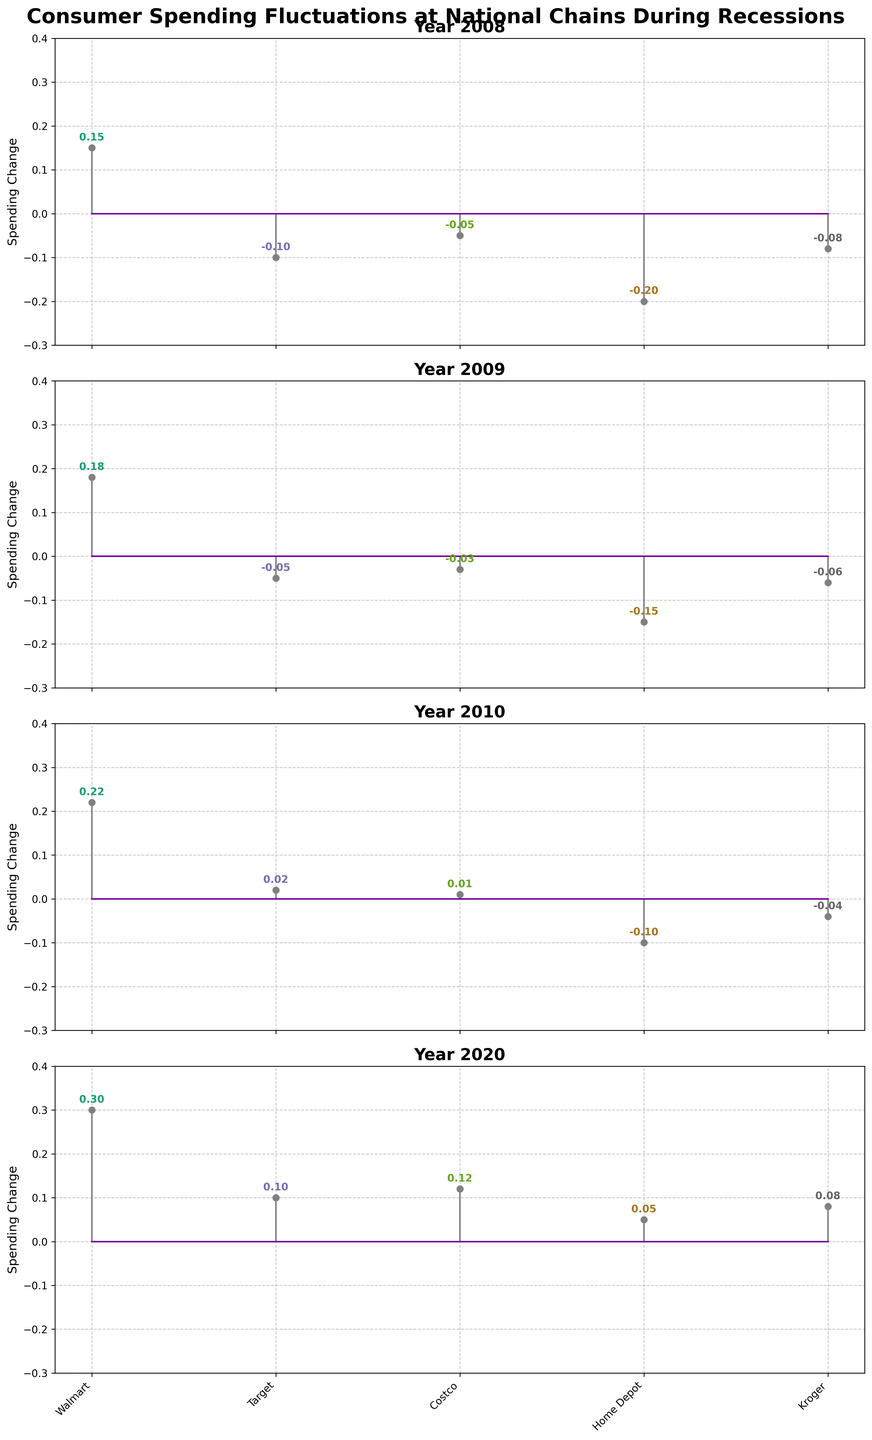Which year shows the highest positive spending change for Walmart? The stem plot for each year indicates the spending changes. By looking at the data points for Walmart, the highest positive spending change is in the year where the value is greatest.
Answer: 2020 What is the spending change of Target in 2008? In the 2008 subplot, the stem plot shows the spending change for each chain. For Target, the value annotated above the stem line is -0.10.
Answer: -0.10 Between 2010 and 2020, how did Home Depot's spending change? Comparing the two stem plots for 2010 and 2020, we see Home Depot's spending change values. They are -0.10 in 2010 and 0.05 in 2020. The change is an increase of 0.15.
Answer: Increased by 0.15 Which chain had the least spending change in 2009? Observing the 2009 subplot, we compare all the chains' spending changes to find the smallest value. Home Depot has the least spending change (-0.15).
Answer: Home Depot Rank the chains by spending change in 2020 from highest to lowest. Analyzing the 2020 subplot, we list the spending changes for each chain and order them from highest to lowest: Walmart (0.30), Costco (0.12), Target (0.10), Kroger (0.08), Home Depot (0.05).
Answer: Walmart, Costco, Target, Kroger, Home Depot In which year did Kroger have the smallest spending change? Reviewing each subplot for the years, we identify Kroger’s spending changes. The smallest change is in 2010 with a value of -0.04.
Answer: 2010 What is the difference in spending change between Costco and Target in 2009? For 2009, looking at the stem plot values for Costco (-0.03) and Target (-0.05), we calculate the difference: -0.03 - (-0.05) = 0.02.
Answer: 0.02 Which chain improved its spending change the most from 2008 to 2020? Comparing every chain from 2008 and 2020, we calculate the change for each. Walmart improved from 0.15 to 0.30, an increase of 0.15, which is the highest improvement among the chains.
Answer: Walmart 